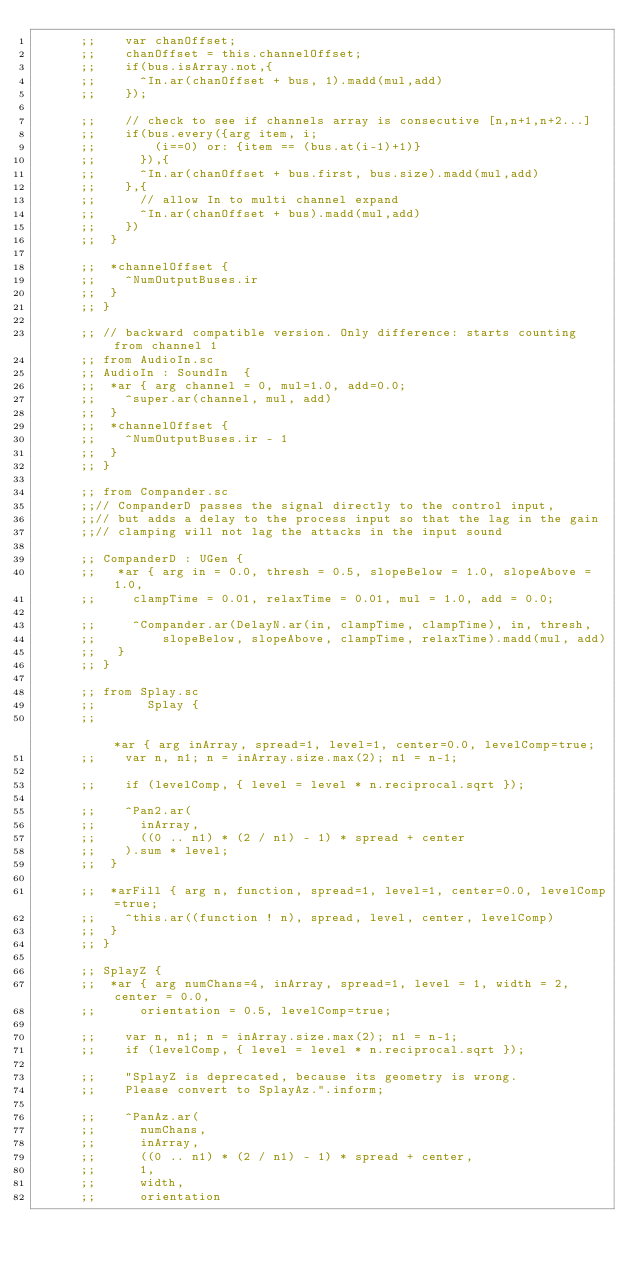Convert code to text. <code><loc_0><loc_0><loc_500><loc_500><_Clojure_>      ;; 		var chanOffset;
      ;; 		chanOffset = this.channelOffset;
      ;; 		if(bus.isArray.not,{
      ;; 			^In.ar(chanOffset + bus, 1).madd(mul,add)
      ;; 		});

      ;; 		// check to see if channels array is consecutive [n,n+1,n+2...]
      ;; 		if(bus.every({arg item, i;
      ;; 				(i==0) or: {item == (bus.at(i-1)+1)}
      ;; 			}),{
      ;; 			^In.ar(chanOffset + bus.first, bus.size).madd(mul,add)
      ;; 		},{
      ;; 			// allow In to multi channel expand
      ;; 			^In.ar(chanOffset + bus).madd(mul,add)
      ;; 		})
      ;; 	}

      ;; 	*channelOffset {
      ;; 		^NumOutputBuses.ir
      ;; 	}
      ;; }

      ;; // backward compatible version. Only difference: starts counting from channel 1
      ;; from AudioIn.sc
      ;; AudioIn : SoundIn  {
      ;; 	*ar { arg channel = 0, mul=1.0, add=0.0;
      ;; 		^super.ar(channel, mul, add)
      ;; 	}
      ;; 	*channelOffset {
      ;; 		^NumOutputBuses.ir - 1
      ;; 	}
      ;; }

      ;; from Compander.sc
      ;;// CompanderD passes the signal directly to the control input,
      ;;// but adds a delay to the process input so that the lag in the gain
      ;;// clamping will not lag the attacks in the input sound

      ;; CompanderD : UGen {
      ;;   *ar { arg in = 0.0, thresh = 0.5, slopeBelow = 1.0, slopeAbove = 1.0,
      ;;     clampTime = 0.01, relaxTime = 0.01, mul = 1.0, add = 0.0;

      ;;     ^Compander.ar(DelayN.ar(in, clampTime, clampTime), in, thresh,
      ;;         slopeBelow, slopeAbove, clampTime, relaxTime).madd(mul, add)
      ;;   }
      ;; }

      ;; from Splay.sc
      ;;       Splay {
      ;;                                                                     	*ar { arg inArray, spread=1, level=1, center=0.0, levelComp=true;
      ;; 		var n, n1; n = inArray.size.max(2); n1 = n-1;

      ;; 		if (levelComp, { level = level * n.reciprocal.sqrt });

      ;; 		^Pan2.ar(
      ;; 			inArray,
      ;; 			((0 .. n1) * (2 / n1) - 1) * spread + center
      ;; 		).sum * level;
      ;; 	}

      ;; 	*arFill { arg n, function, spread=1, level=1, center=0.0, levelComp=true;
      ;; 		^this.ar((function ! n), spread, level, center, levelComp)
      ;; 	}
      ;; }

      ;; SplayZ {
      ;; 	*ar { arg numChans=4, inArray, spread=1, level = 1, width = 2, center = 0.0,
      ;; 			orientation = 0.5, levelComp=true;

      ;; 		var n, n1; n = inArray.size.max(2); n1 = n-1;
      ;; 		if (levelComp, { level = level * n.reciprocal.sqrt });

      ;; 		"SplayZ is deprecated, because its geometry is wrong.
      ;; 		Please convert to SplayAz.".inform;

      ;; 		^PanAz.ar(
      ;; 			numChans,
      ;; 			inArray,
      ;; 			((0 .. n1) * (2 / n1) - 1) * spread + center,
      ;; 			1,
      ;; 			width,
      ;; 			orientation</code> 